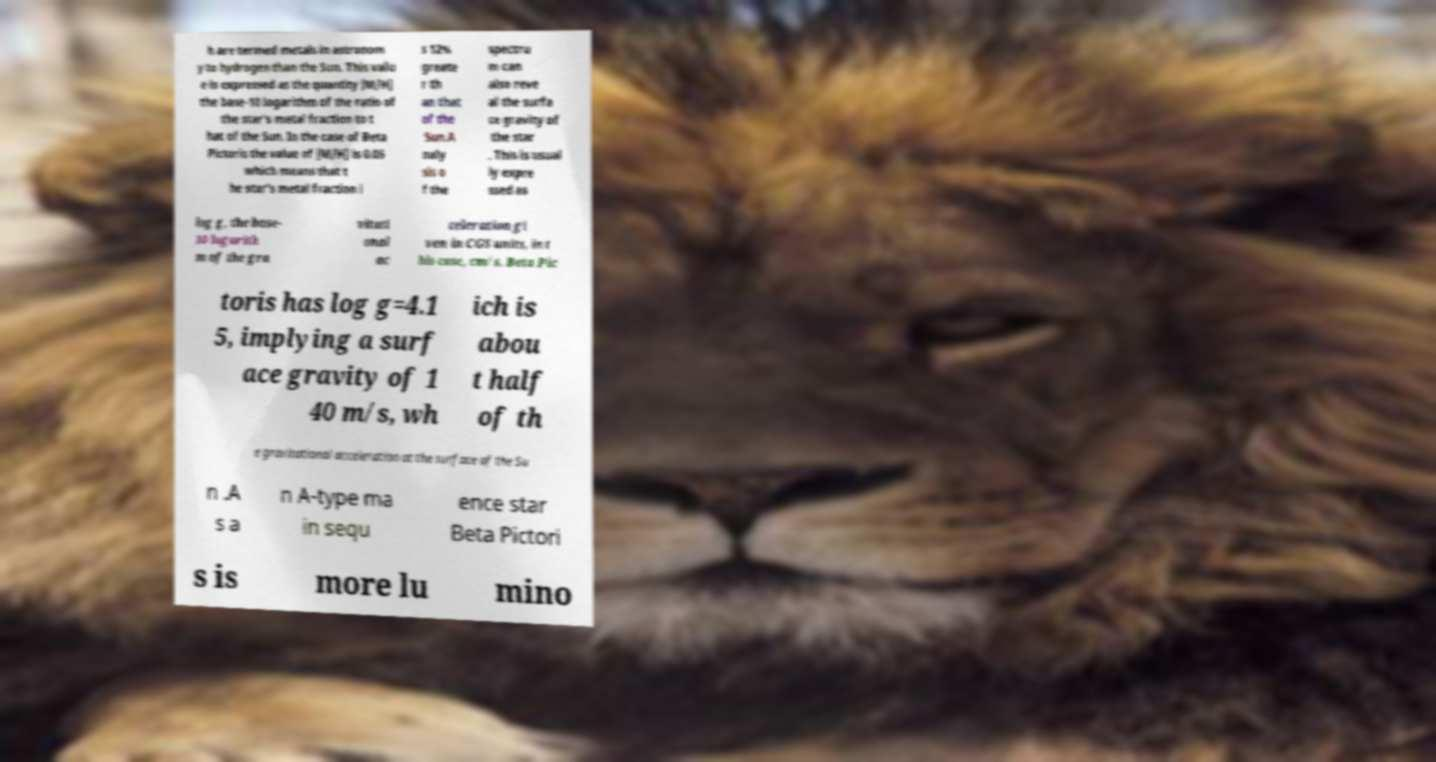Could you extract and type out the text from this image? h are termed metals in astronom y to hydrogen than the Sun. This valu e is expressed as the quantity [M/H] the base-10 logarithm of the ratio of the star's metal fraction to t hat of the Sun. In the case of Beta Pictoris the value of [M/H] is 0.05 which means that t he star's metal fraction i s 12% greate r th an that of the Sun.A naly sis o f the spectru m can also reve al the surfa ce gravity of the star . This is usual ly expre ssed as log g, the base- 10 logarith m of the gra vitati onal ac celeration gi ven in CGS units, in t his case, cm/s. Beta Pic toris has log g=4.1 5, implying a surf ace gravity of 1 40 m/s, wh ich is abou t half of th e gravitational acceleration at the surface of the Su n .A s a n A-type ma in sequ ence star Beta Pictori s is more lu mino 